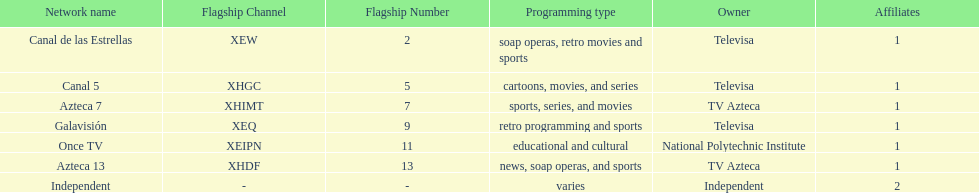What is the number of networks that are owned by televisa? 3. 